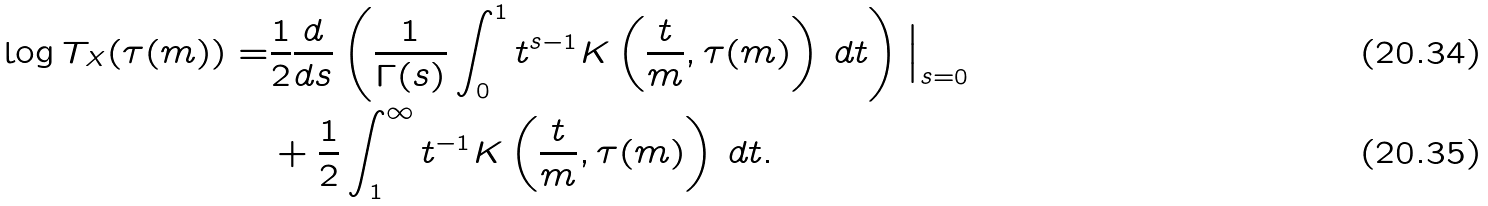Convert formula to latex. <formula><loc_0><loc_0><loc_500><loc_500>\log T _ { X } ( \tau ( m ) ) = & \frac { 1 } { 2 } \frac { d } { d s } \left ( \frac { 1 } { \Gamma ( s ) } \int _ { 0 } ^ { 1 } t ^ { s - 1 } K \left ( \frac { t } { m } , \tau ( m ) \right ) \, d t \right ) \Big | _ { s = 0 } \\ & + \frac { 1 } { 2 } \int _ { 1 } ^ { \infty } t ^ { - 1 } K \left ( \frac { t } { m } , \tau ( m ) \right ) \, d t .</formula> 